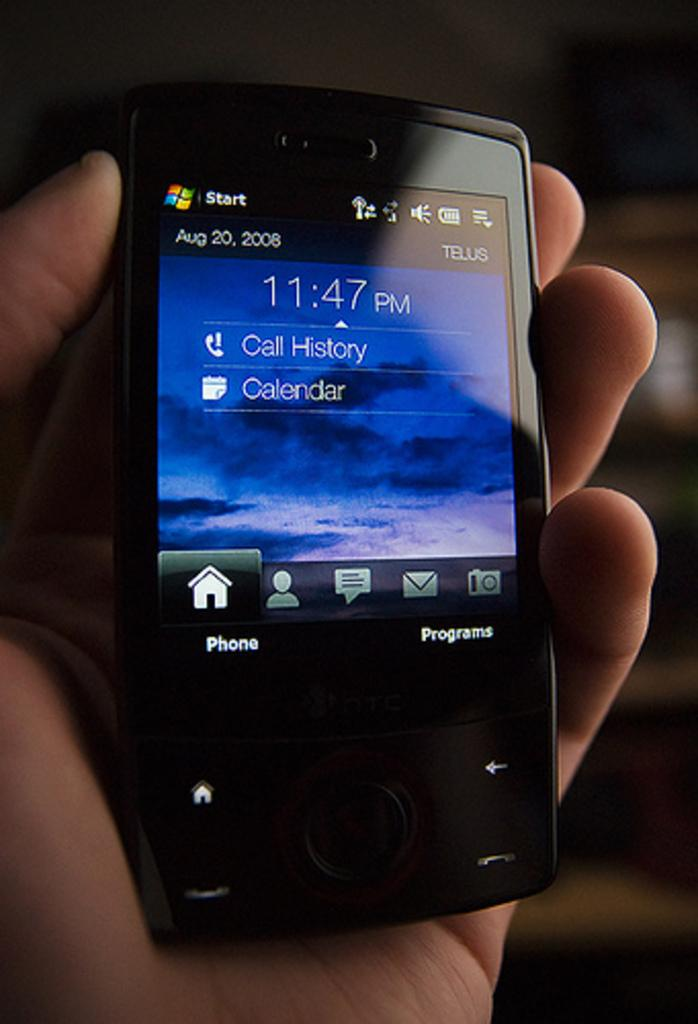<image>
Share a concise interpretation of the image provided. a phone that shows the time of 11:47 pm, 